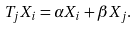<formula> <loc_0><loc_0><loc_500><loc_500>T _ { j } X _ { i } = \alpha X _ { i } + \beta X _ { j } .</formula> 